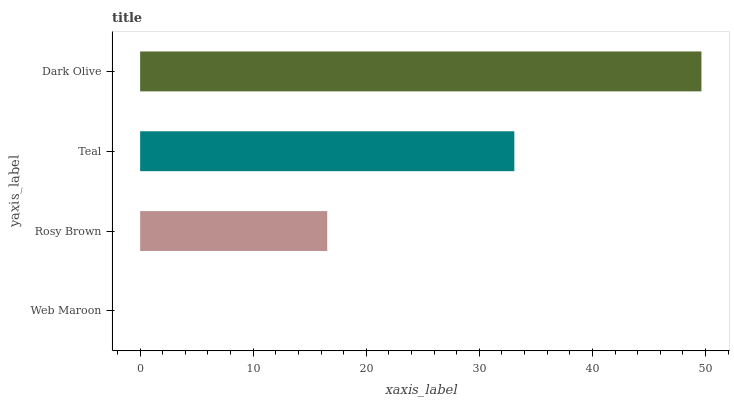Is Web Maroon the minimum?
Answer yes or no. Yes. Is Dark Olive the maximum?
Answer yes or no. Yes. Is Rosy Brown the minimum?
Answer yes or no. No. Is Rosy Brown the maximum?
Answer yes or no. No. Is Rosy Brown greater than Web Maroon?
Answer yes or no. Yes. Is Web Maroon less than Rosy Brown?
Answer yes or no. Yes. Is Web Maroon greater than Rosy Brown?
Answer yes or no. No. Is Rosy Brown less than Web Maroon?
Answer yes or no. No. Is Teal the high median?
Answer yes or no. Yes. Is Rosy Brown the low median?
Answer yes or no. Yes. Is Rosy Brown the high median?
Answer yes or no. No. Is Teal the low median?
Answer yes or no. No. 